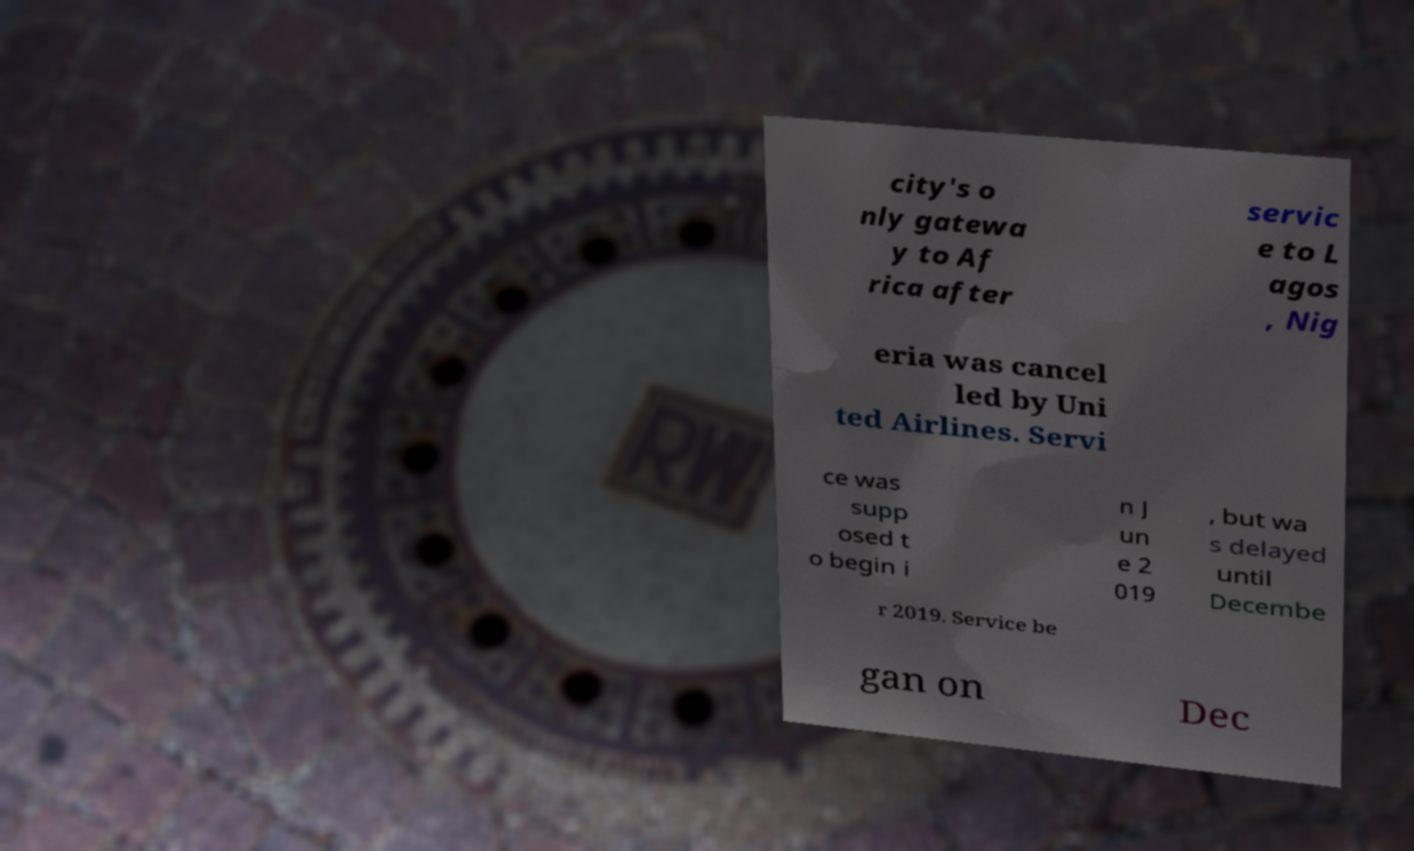There's text embedded in this image that I need extracted. Can you transcribe it verbatim? city's o nly gatewa y to Af rica after servic e to L agos , Nig eria was cancel led by Uni ted Airlines. Servi ce was supp osed t o begin i n J un e 2 019 , but wa s delayed until Decembe r 2019. Service be gan on Dec 